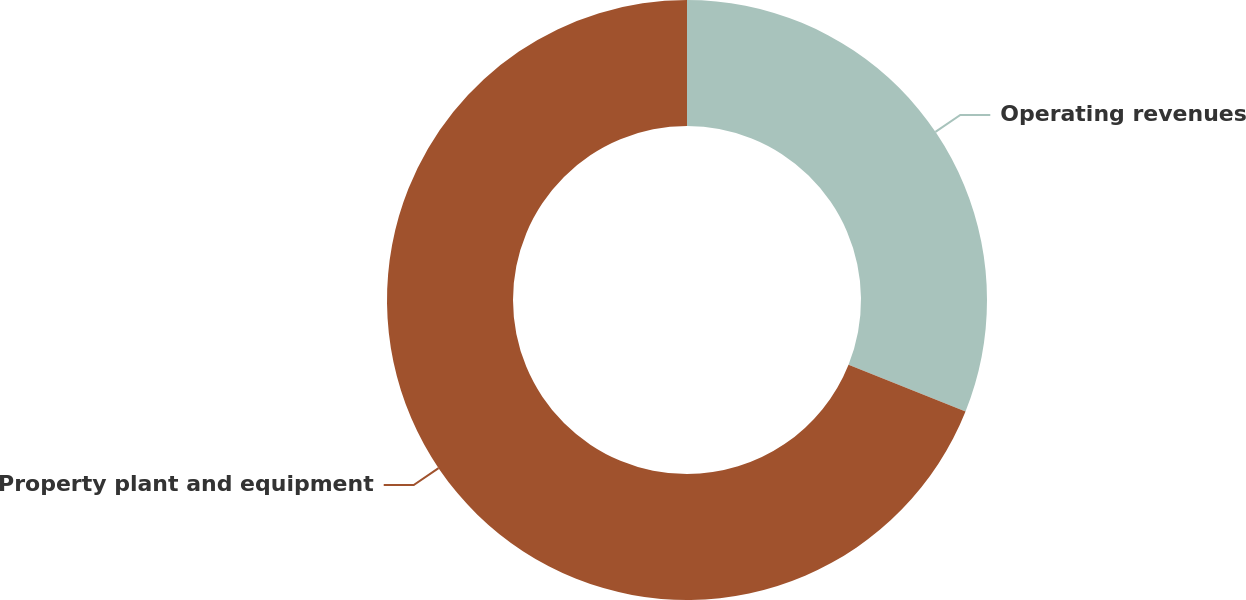Convert chart. <chart><loc_0><loc_0><loc_500><loc_500><pie_chart><fcel>Operating revenues<fcel>Property plant and equipment<nl><fcel>31.06%<fcel>68.94%<nl></chart> 